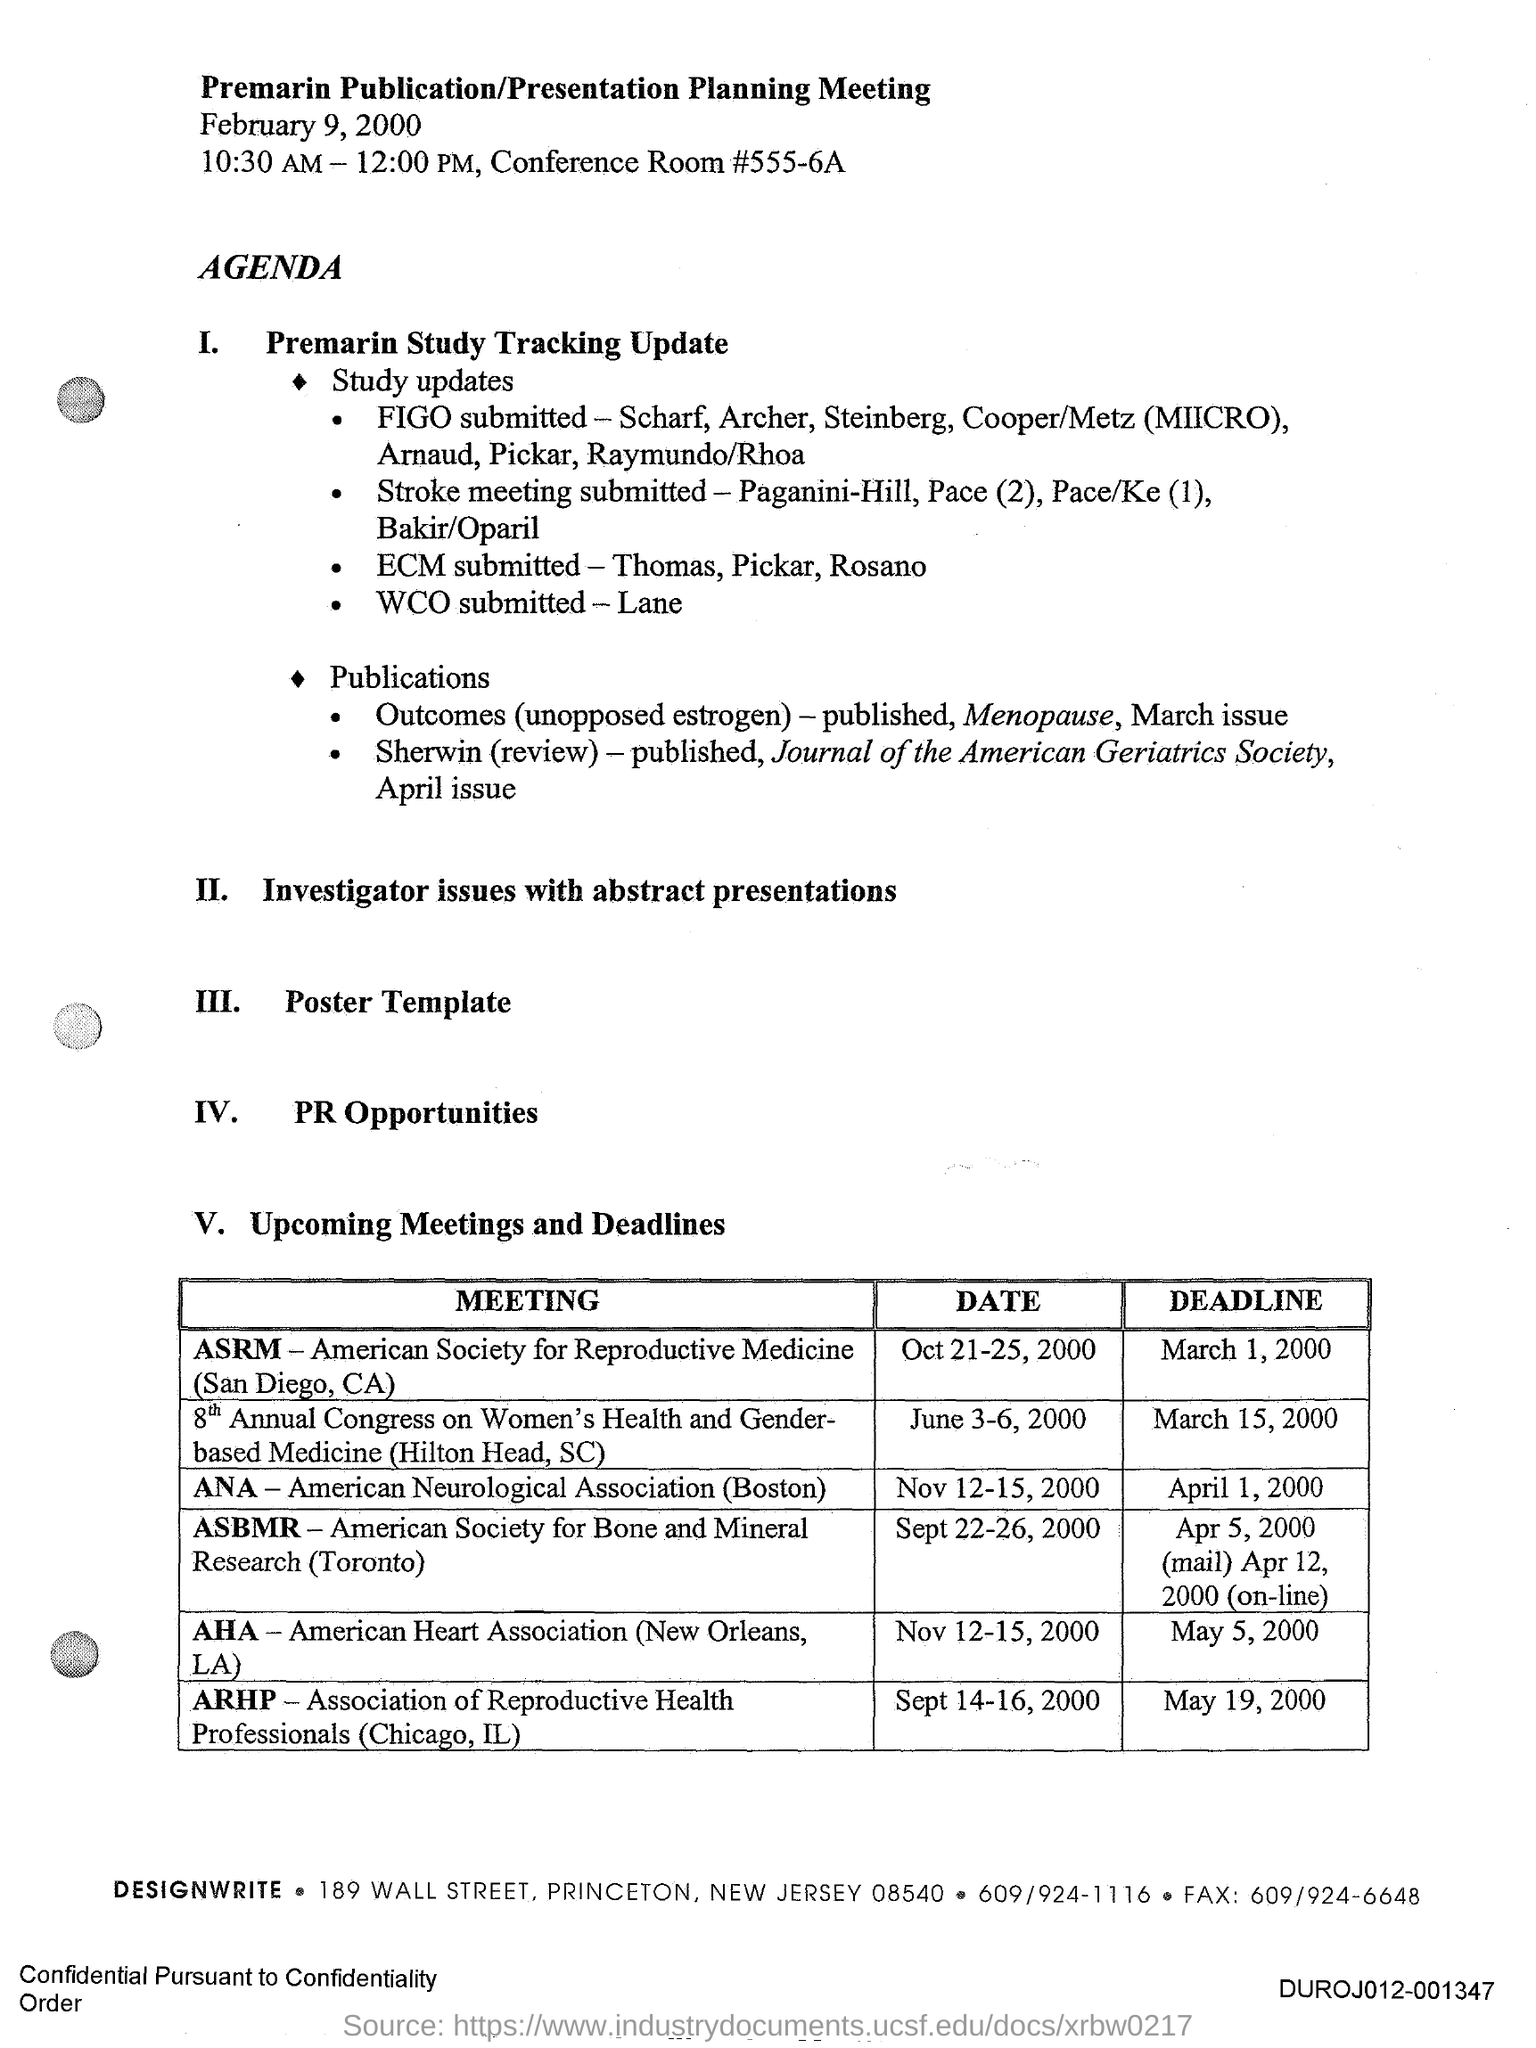What is the conference room no #?
Your answer should be very brief. #555-6A. 